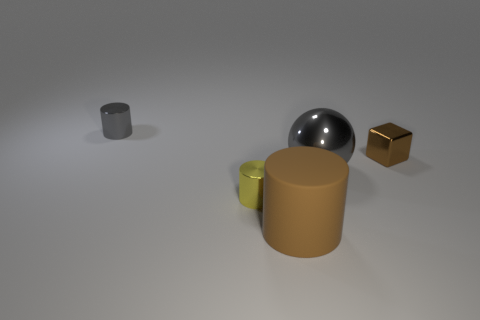The big object that is the same color as the cube is what shape?
Ensure brevity in your answer.  Cylinder. How many blocks have the same size as the yellow thing?
Provide a succinct answer. 1. There is a brown thing behind the brown object that is in front of the gray thing that is in front of the small gray cylinder; what is its material?
Your answer should be compact. Metal. How many things are either small cyan cylinders or small yellow metal cylinders?
Provide a short and direct response. 1. Are there any other things that are the same material as the big cylinder?
Make the answer very short. No. The small gray thing is what shape?
Your answer should be compact. Cylinder. There is a metal thing right of the gray object on the right side of the tiny gray cylinder; what is its shape?
Your answer should be compact. Cube. Are the gray object that is in front of the metal block and the tiny yellow thing made of the same material?
Your response must be concise. Yes. How many blue objects are either small cylinders or blocks?
Your answer should be compact. 0. Is there a tiny metal cylinder that has the same color as the large matte thing?
Give a very brief answer. No. 